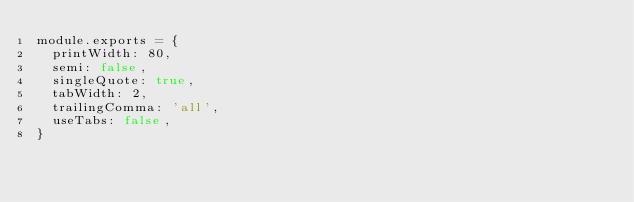Convert code to text. <code><loc_0><loc_0><loc_500><loc_500><_JavaScript_>module.exports = {
  printWidth: 80,
  semi: false,
  singleQuote: true,
  tabWidth: 2,
  trailingComma: 'all',
  useTabs: false,
}
</code> 